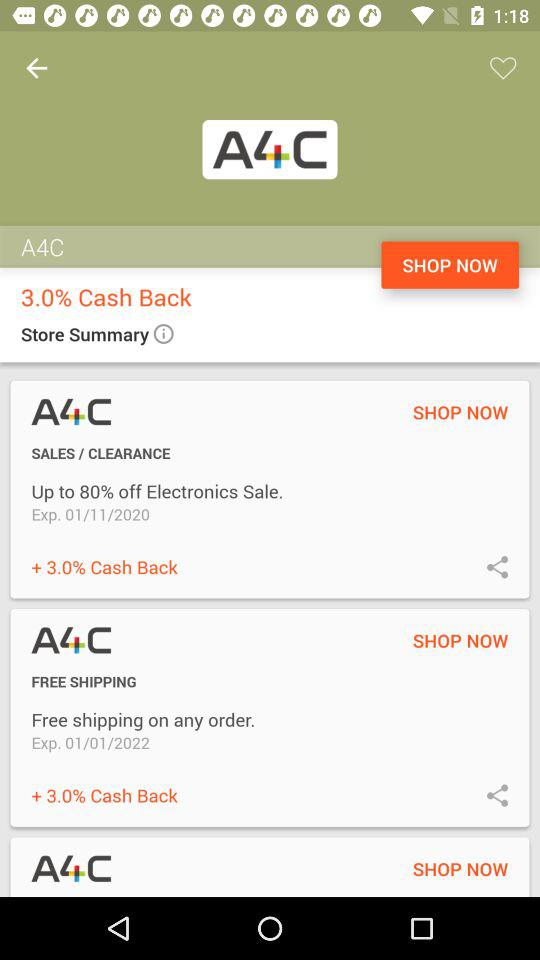What is the expiration date of the "FREE SHIPPING" coupon? The expiration date is January 1, 2022. 